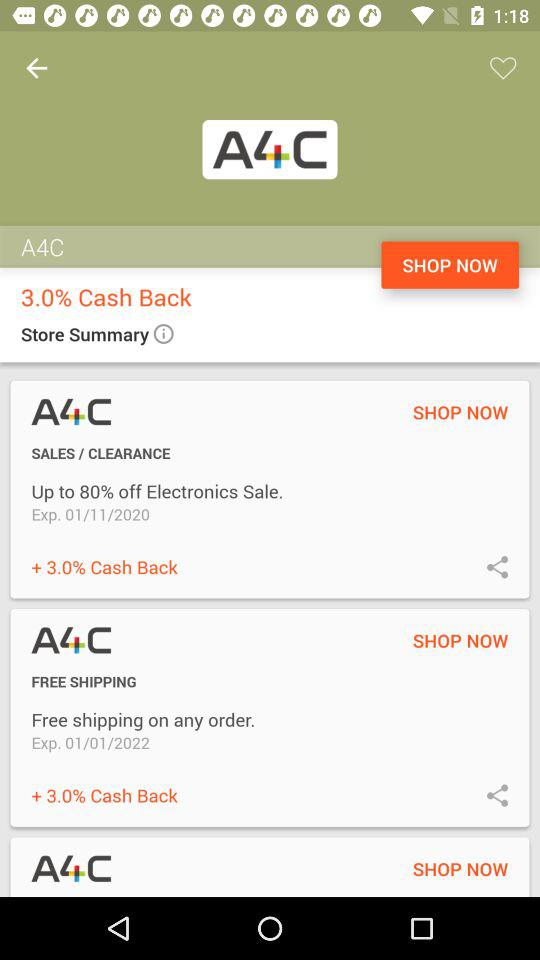What is the expiration date of the "FREE SHIPPING" coupon? The expiration date is January 1, 2022. 